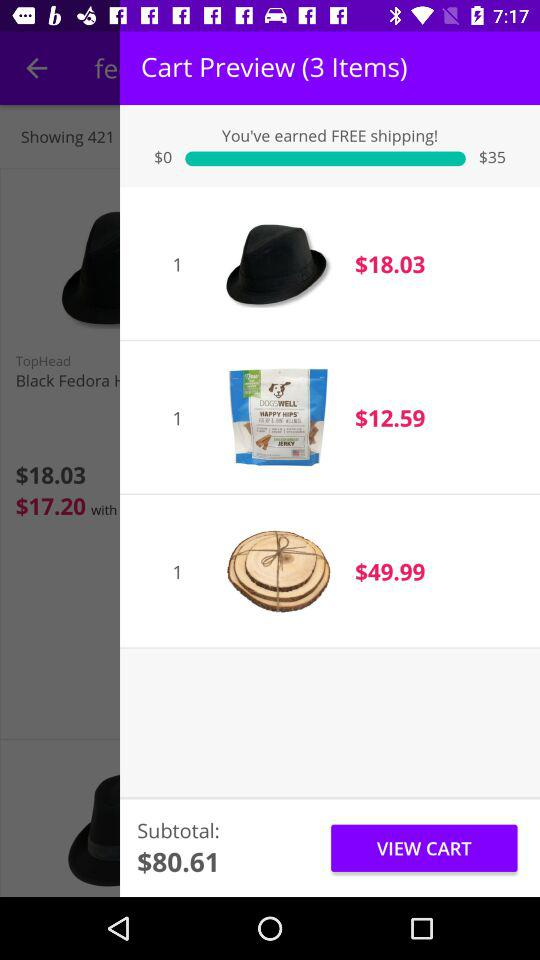What is the total price of the items in the cart?
Answer the question using a single word or phrase. $80.61 